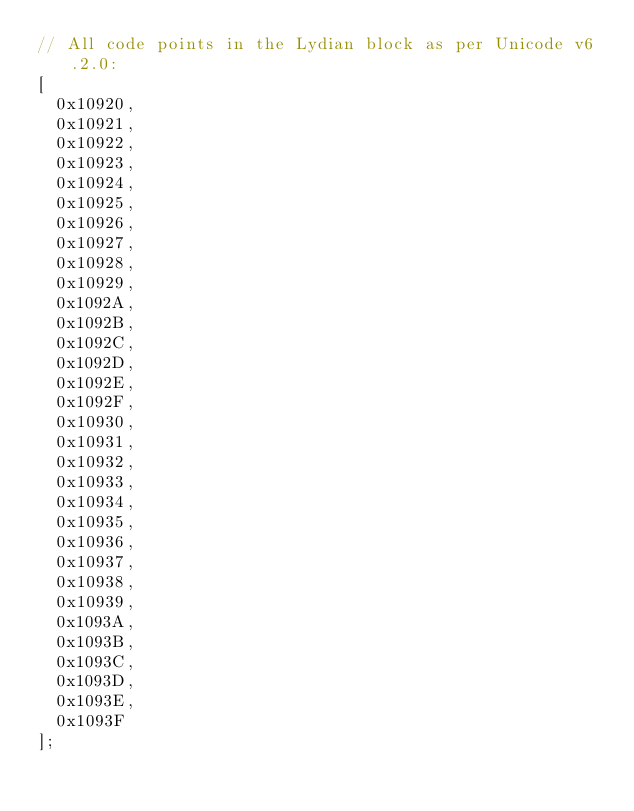<code> <loc_0><loc_0><loc_500><loc_500><_JavaScript_>// All code points in the Lydian block as per Unicode v6.2.0:
[
	0x10920,
	0x10921,
	0x10922,
	0x10923,
	0x10924,
	0x10925,
	0x10926,
	0x10927,
	0x10928,
	0x10929,
	0x1092A,
	0x1092B,
	0x1092C,
	0x1092D,
	0x1092E,
	0x1092F,
	0x10930,
	0x10931,
	0x10932,
	0x10933,
	0x10934,
	0x10935,
	0x10936,
	0x10937,
	0x10938,
	0x10939,
	0x1093A,
	0x1093B,
	0x1093C,
	0x1093D,
	0x1093E,
	0x1093F
];</code> 